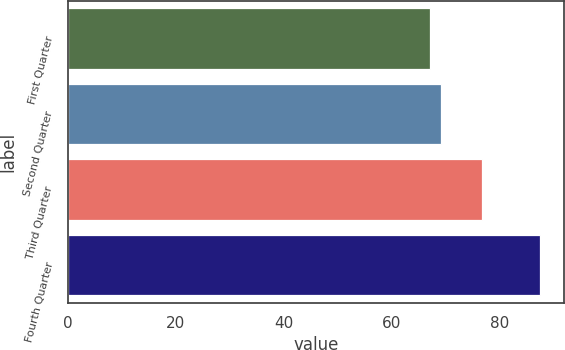<chart> <loc_0><loc_0><loc_500><loc_500><bar_chart><fcel>First Quarter<fcel>Second Quarter<fcel>Third Quarter<fcel>Fourth Quarter<nl><fcel>67.05<fcel>69.09<fcel>76.7<fcel>87.5<nl></chart> 